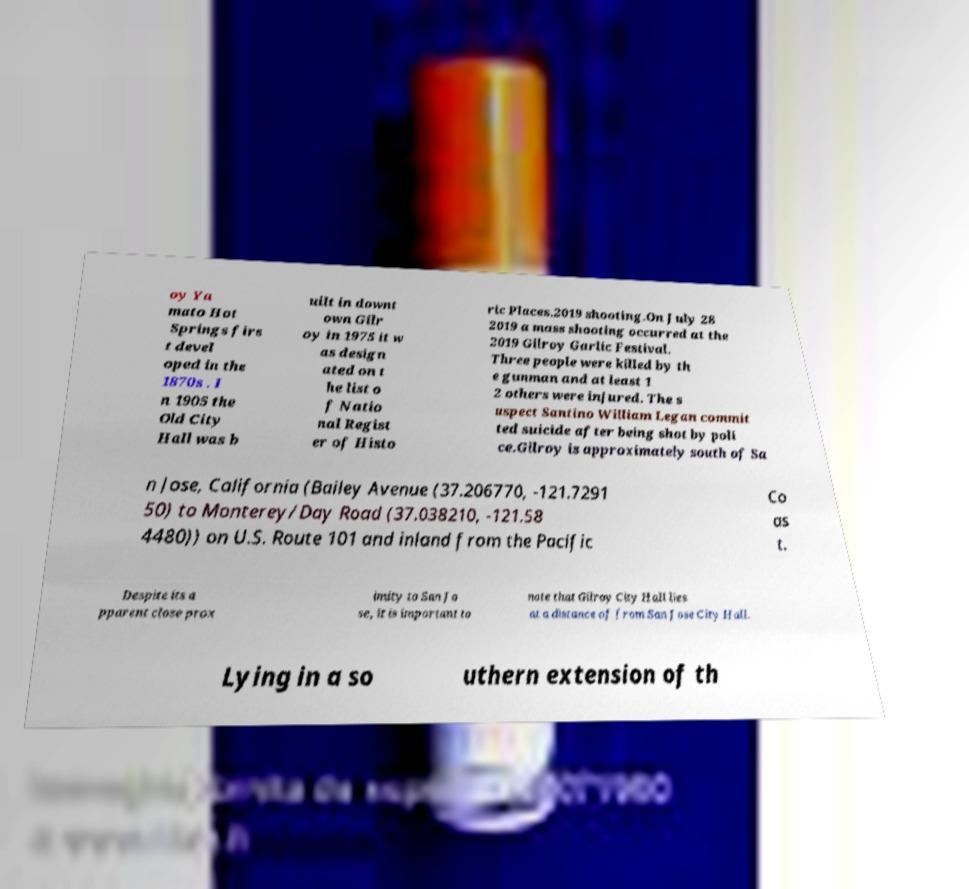Please identify and transcribe the text found in this image. oy Ya mato Hot Springs firs t devel oped in the 1870s . I n 1905 the Old City Hall was b uilt in downt own Gilr oy in 1975 it w as design ated on t he list o f Natio nal Regist er of Histo ric Places.2019 shooting.On July 28 2019 a mass shooting occurred at the 2019 Gilroy Garlic Festival. Three people were killed by th e gunman and at least 1 2 others were injured. The s uspect Santino William Legan commit ted suicide after being shot by poli ce.Gilroy is approximately south of Sa n Jose, California (Bailey Avenue (37.206770, -121.7291 50) to Monterey/Day Road (37.038210, -121.58 4480)) on U.S. Route 101 and inland from the Pacific Co as t. Despite its a pparent close prox imity to San Jo se, it is important to note that Gilroy City Hall lies at a distance of from San Jose City Hall. Lying in a so uthern extension of th 